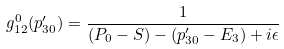Convert formula to latex. <formula><loc_0><loc_0><loc_500><loc_500>g _ { 1 2 } ^ { 0 } ( p _ { 3 0 } ^ { \prime } ) = \frac { 1 } { ( P _ { 0 } - S ) - ( p _ { 3 0 } ^ { \prime } - E _ { 3 } ) + i \epsilon }</formula> 